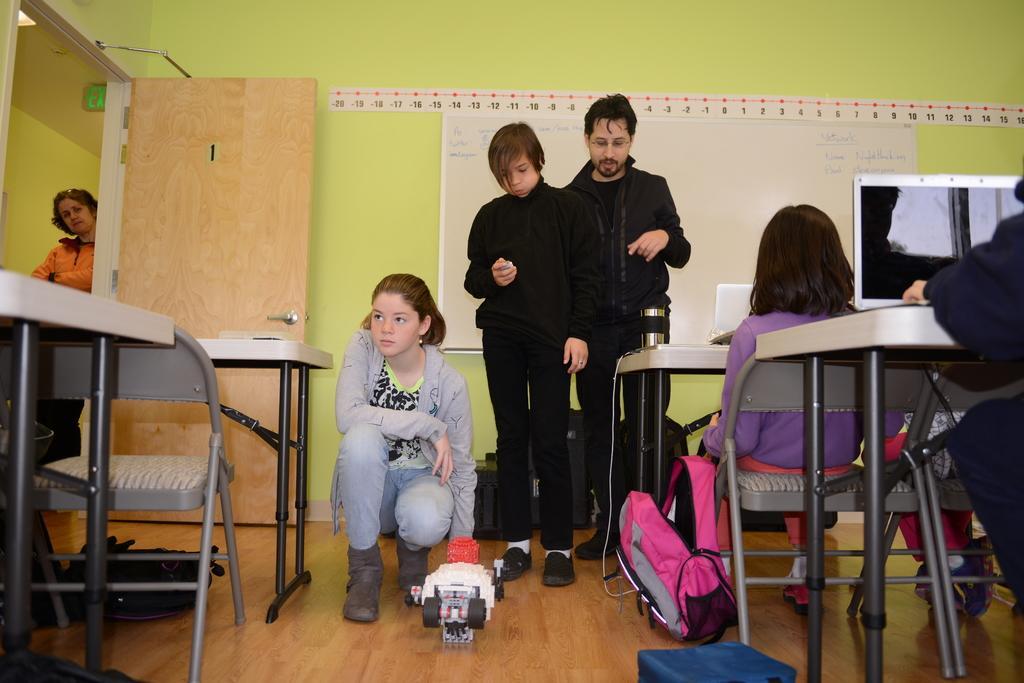Please provide a concise description of this image. In the center they were three people,one of the lady is sitting and the two were standing and the right side they were few people were sitting on the chair. And beside them there is a backpack, one toy and wall. And in the right side the lady staring on them. 